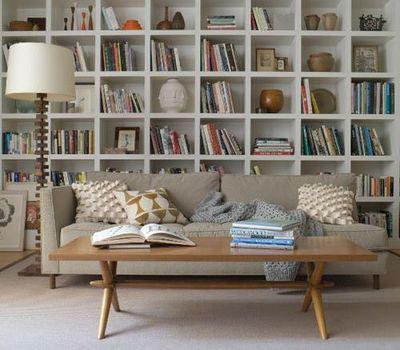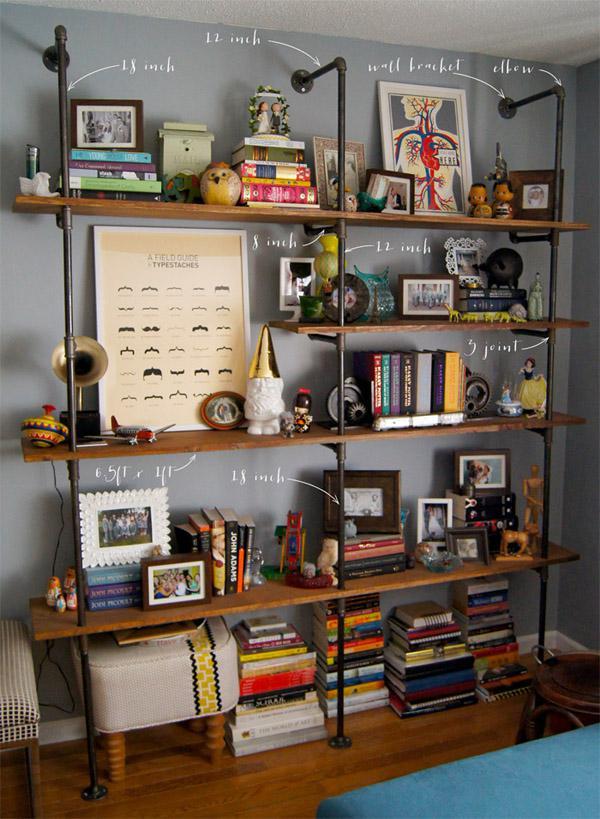The first image is the image on the left, the second image is the image on the right. Given the left and right images, does the statement "An image features a round white table in front of a horizontal couch with assorted pillows, which is in front of a white bookcase." hold true? Answer yes or no. No. The first image is the image on the left, the second image is the image on the right. For the images shown, is this caption "One of the tables is small, white, and round." true? Answer yes or no. No. 